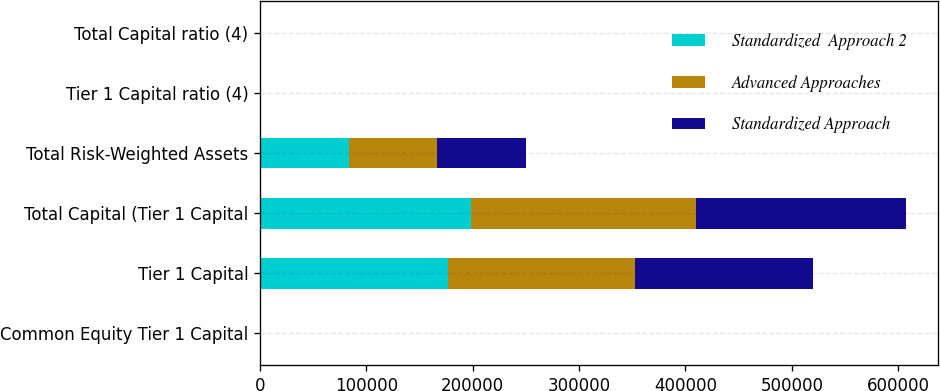<chart> <loc_0><loc_0><loc_500><loc_500><stacked_bar_chart><ecel><fcel>Common Equity Tier 1 Capital<fcel>Tier 1 Capital<fcel>Total Capital (Tier 1 Capital<fcel>Total Risk-Weighted Assets<fcel>Tier 1 Capital ratio (4)<fcel>Total Capital ratio (4)<nl><fcel>Standardized  Approach 2<fcel>14.6<fcel>176420<fcel>198746<fcel>83340.8<fcel>14.81<fcel>16.69<nl><fcel>Advanced Approaches<fcel>15.27<fcel>176420<fcel>211115<fcel>83340.8<fcel>15.49<fcel>18.54<nl><fcel>Standardized Approach<fcel>13.76<fcel>166663<fcel>197707<fcel>83340.8<fcel>13.76<fcel>16.32<nl></chart> 